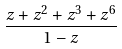Convert formula to latex. <formula><loc_0><loc_0><loc_500><loc_500>\frac { z + z ^ { 2 } + z ^ { 3 } + z ^ { 6 } } { 1 - z }</formula> 